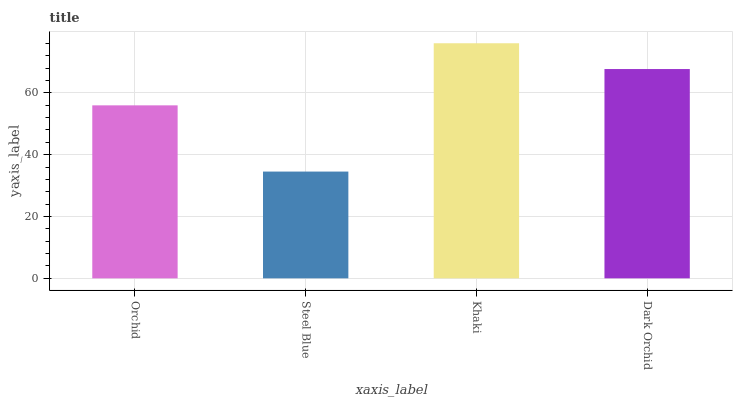Is Steel Blue the minimum?
Answer yes or no. Yes. Is Khaki the maximum?
Answer yes or no. Yes. Is Khaki the minimum?
Answer yes or no. No. Is Steel Blue the maximum?
Answer yes or no. No. Is Khaki greater than Steel Blue?
Answer yes or no. Yes. Is Steel Blue less than Khaki?
Answer yes or no. Yes. Is Steel Blue greater than Khaki?
Answer yes or no. No. Is Khaki less than Steel Blue?
Answer yes or no. No. Is Dark Orchid the high median?
Answer yes or no. Yes. Is Orchid the low median?
Answer yes or no. Yes. Is Steel Blue the high median?
Answer yes or no. No. Is Dark Orchid the low median?
Answer yes or no. No. 